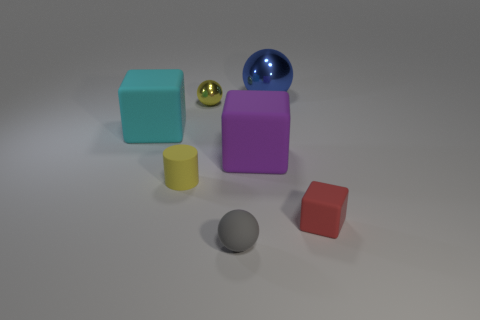How are the spheres different from each other? The spheres in the image display distinct differences. The blue sphere has a high reflective surface, likely representing a material like glass, while the gold sphere has a metallic sheen, and the grey one appears to be matte, hinting at a rubber-like material. Additionally, the blue and gold spheres are larger than the grey sphere. 